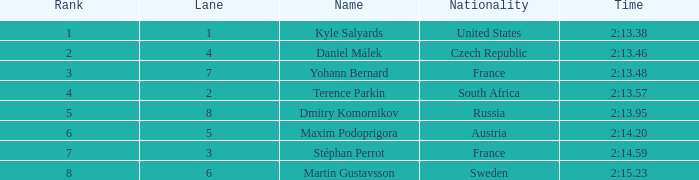What was the most inferior rank of maxim podoprigora? 6.0. 